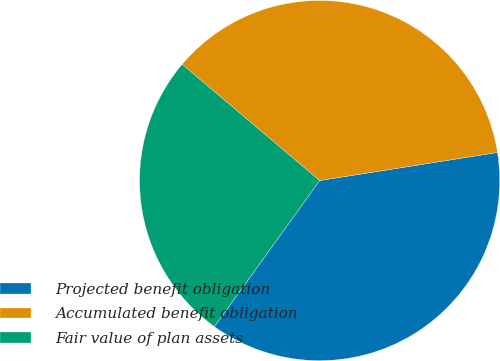Convert chart to OTSL. <chart><loc_0><loc_0><loc_500><loc_500><pie_chart><fcel>Projected benefit obligation<fcel>Accumulated benefit obligation<fcel>Fair value of plan assets<nl><fcel>37.43%<fcel>36.34%<fcel>26.24%<nl></chart> 